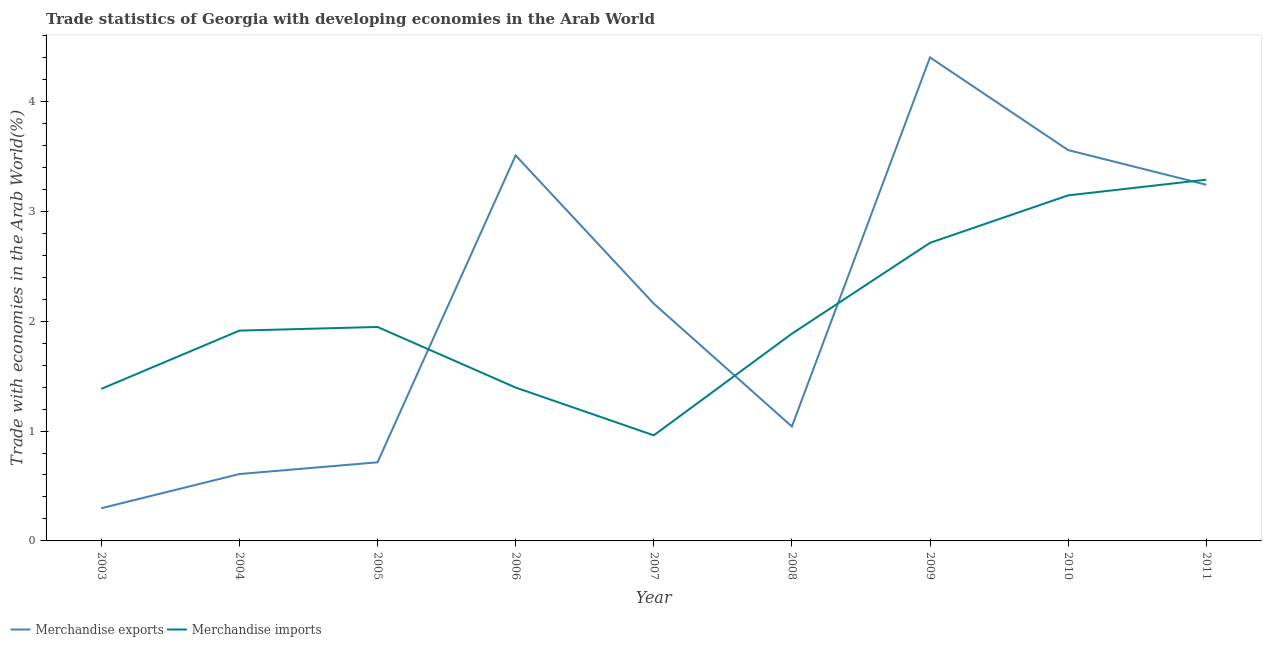Does the line corresponding to merchandise imports intersect with the line corresponding to merchandise exports?
Ensure brevity in your answer.  Yes. Is the number of lines equal to the number of legend labels?
Keep it short and to the point. Yes. What is the merchandise imports in 2004?
Make the answer very short. 1.91. Across all years, what is the maximum merchandise imports?
Your answer should be very brief. 3.29. Across all years, what is the minimum merchandise exports?
Your response must be concise. 0.3. In which year was the merchandise imports maximum?
Your answer should be compact. 2011. What is the total merchandise imports in the graph?
Your answer should be compact. 18.63. What is the difference between the merchandise imports in 2004 and that in 2008?
Provide a short and direct response. 0.03. What is the difference between the merchandise exports in 2003 and the merchandise imports in 2009?
Offer a terse response. -2.42. What is the average merchandise imports per year?
Keep it short and to the point. 2.07. In the year 2011, what is the difference between the merchandise exports and merchandise imports?
Offer a very short reply. -0.05. In how many years, is the merchandise exports greater than 4 %?
Your answer should be very brief. 1. What is the ratio of the merchandise imports in 2004 to that in 2009?
Ensure brevity in your answer.  0.71. Is the merchandise exports in 2007 less than that in 2008?
Ensure brevity in your answer.  No. Is the difference between the merchandise imports in 2003 and 2007 greater than the difference between the merchandise exports in 2003 and 2007?
Your answer should be compact. Yes. What is the difference between the highest and the second highest merchandise imports?
Your response must be concise. 0.14. What is the difference between the highest and the lowest merchandise exports?
Give a very brief answer. 4.1. In how many years, is the merchandise imports greater than the average merchandise imports taken over all years?
Keep it short and to the point. 3. How many lines are there?
Your answer should be very brief. 2. What is the difference between two consecutive major ticks on the Y-axis?
Your answer should be very brief. 1. Does the graph contain grids?
Give a very brief answer. No. How many legend labels are there?
Provide a short and direct response. 2. How are the legend labels stacked?
Provide a short and direct response. Horizontal. What is the title of the graph?
Keep it short and to the point. Trade statistics of Georgia with developing economies in the Arab World. What is the label or title of the X-axis?
Provide a short and direct response. Year. What is the label or title of the Y-axis?
Your answer should be compact. Trade with economies in the Arab World(%). What is the Trade with economies in the Arab World(%) of Merchandise exports in 2003?
Provide a short and direct response. 0.3. What is the Trade with economies in the Arab World(%) in Merchandise imports in 2003?
Provide a short and direct response. 1.38. What is the Trade with economies in the Arab World(%) in Merchandise exports in 2004?
Your answer should be compact. 0.61. What is the Trade with economies in the Arab World(%) of Merchandise imports in 2004?
Give a very brief answer. 1.91. What is the Trade with economies in the Arab World(%) of Merchandise exports in 2005?
Provide a short and direct response. 0.72. What is the Trade with economies in the Arab World(%) of Merchandise imports in 2005?
Your response must be concise. 1.95. What is the Trade with economies in the Arab World(%) in Merchandise exports in 2006?
Offer a very short reply. 3.51. What is the Trade with economies in the Arab World(%) of Merchandise imports in 2006?
Make the answer very short. 1.4. What is the Trade with economies in the Arab World(%) in Merchandise exports in 2007?
Your response must be concise. 2.16. What is the Trade with economies in the Arab World(%) in Merchandise imports in 2007?
Offer a very short reply. 0.96. What is the Trade with economies in the Arab World(%) in Merchandise exports in 2008?
Provide a succinct answer. 1.04. What is the Trade with economies in the Arab World(%) of Merchandise imports in 2008?
Your response must be concise. 1.89. What is the Trade with economies in the Arab World(%) of Merchandise exports in 2009?
Your answer should be very brief. 4.4. What is the Trade with economies in the Arab World(%) of Merchandise imports in 2009?
Make the answer very short. 2.71. What is the Trade with economies in the Arab World(%) of Merchandise exports in 2010?
Make the answer very short. 3.56. What is the Trade with economies in the Arab World(%) in Merchandise imports in 2010?
Your answer should be compact. 3.15. What is the Trade with economies in the Arab World(%) of Merchandise exports in 2011?
Provide a succinct answer. 3.24. What is the Trade with economies in the Arab World(%) in Merchandise imports in 2011?
Keep it short and to the point. 3.29. Across all years, what is the maximum Trade with economies in the Arab World(%) in Merchandise exports?
Your answer should be compact. 4.4. Across all years, what is the maximum Trade with economies in the Arab World(%) in Merchandise imports?
Offer a very short reply. 3.29. Across all years, what is the minimum Trade with economies in the Arab World(%) of Merchandise exports?
Your answer should be compact. 0.3. Across all years, what is the minimum Trade with economies in the Arab World(%) in Merchandise imports?
Ensure brevity in your answer.  0.96. What is the total Trade with economies in the Arab World(%) in Merchandise exports in the graph?
Provide a short and direct response. 19.53. What is the total Trade with economies in the Arab World(%) in Merchandise imports in the graph?
Provide a succinct answer. 18.63. What is the difference between the Trade with economies in the Arab World(%) in Merchandise exports in 2003 and that in 2004?
Keep it short and to the point. -0.31. What is the difference between the Trade with economies in the Arab World(%) in Merchandise imports in 2003 and that in 2004?
Provide a succinct answer. -0.53. What is the difference between the Trade with economies in the Arab World(%) in Merchandise exports in 2003 and that in 2005?
Give a very brief answer. -0.42. What is the difference between the Trade with economies in the Arab World(%) of Merchandise imports in 2003 and that in 2005?
Your answer should be very brief. -0.56. What is the difference between the Trade with economies in the Arab World(%) in Merchandise exports in 2003 and that in 2006?
Keep it short and to the point. -3.21. What is the difference between the Trade with economies in the Arab World(%) of Merchandise imports in 2003 and that in 2006?
Offer a terse response. -0.01. What is the difference between the Trade with economies in the Arab World(%) in Merchandise exports in 2003 and that in 2007?
Give a very brief answer. -1.86. What is the difference between the Trade with economies in the Arab World(%) in Merchandise imports in 2003 and that in 2007?
Your response must be concise. 0.42. What is the difference between the Trade with economies in the Arab World(%) of Merchandise exports in 2003 and that in 2008?
Offer a very short reply. -0.74. What is the difference between the Trade with economies in the Arab World(%) of Merchandise imports in 2003 and that in 2008?
Provide a succinct answer. -0.5. What is the difference between the Trade with economies in the Arab World(%) of Merchandise exports in 2003 and that in 2009?
Offer a very short reply. -4.1. What is the difference between the Trade with economies in the Arab World(%) of Merchandise imports in 2003 and that in 2009?
Offer a very short reply. -1.33. What is the difference between the Trade with economies in the Arab World(%) of Merchandise exports in 2003 and that in 2010?
Give a very brief answer. -3.26. What is the difference between the Trade with economies in the Arab World(%) of Merchandise imports in 2003 and that in 2010?
Offer a very short reply. -1.76. What is the difference between the Trade with economies in the Arab World(%) of Merchandise exports in 2003 and that in 2011?
Your answer should be compact. -2.94. What is the difference between the Trade with economies in the Arab World(%) in Merchandise imports in 2003 and that in 2011?
Make the answer very short. -1.9. What is the difference between the Trade with economies in the Arab World(%) of Merchandise exports in 2004 and that in 2005?
Offer a terse response. -0.11. What is the difference between the Trade with economies in the Arab World(%) of Merchandise imports in 2004 and that in 2005?
Provide a succinct answer. -0.03. What is the difference between the Trade with economies in the Arab World(%) in Merchandise exports in 2004 and that in 2006?
Keep it short and to the point. -2.9. What is the difference between the Trade with economies in the Arab World(%) of Merchandise imports in 2004 and that in 2006?
Give a very brief answer. 0.52. What is the difference between the Trade with economies in the Arab World(%) of Merchandise exports in 2004 and that in 2007?
Give a very brief answer. -1.55. What is the difference between the Trade with economies in the Arab World(%) in Merchandise imports in 2004 and that in 2007?
Give a very brief answer. 0.95. What is the difference between the Trade with economies in the Arab World(%) in Merchandise exports in 2004 and that in 2008?
Make the answer very short. -0.43. What is the difference between the Trade with economies in the Arab World(%) of Merchandise imports in 2004 and that in 2008?
Give a very brief answer. 0.03. What is the difference between the Trade with economies in the Arab World(%) in Merchandise exports in 2004 and that in 2009?
Provide a short and direct response. -3.79. What is the difference between the Trade with economies in the Arab World(%) in Merchandise imports in 2004 and that in 2009?
Your answer should be very brief. -0.8. What is the difference between the Trade with economies in the Arab World(%) in Merchandise exports in 2004 and that in 2010?
Your answer should be very brief. -2.95. What is the difference between the Trade with economies in the Arab World(%) in Merchandise imports in 2004 and that in 2010?
Provide a succinct answer. -1.23. What is the difference between the Trade with economies in the Arab World(%) in Merchandise exports in 2004 and that in 2011?
Give a very brief answer. -2.63. What is the difference between the Trade with economies in the Arab World(%) in Merchandise imports in 2004 and that in 2011?
Offer a very short reply. -1.37. What is the difference between the Trade with economies in the Arab World(%) of Merchandise exports in 2005 and that in 2006?
Your answer should be compact. -2.79. What is the difference between the Trade with economies in the Arab World(%) of Merchandise imports in 2005 and that in 2006?
Your answer should be compact. 0.55. What is the difference between the Trade with economies in the Arab World(%) of Merchandise exports in 2005 and that in 2007?
Your response must be concise. -1.44. What is the difference between the Trade with economies in the Arab World(%) of Merchandise imports in 2005 and that in 2007?
Your answer should be compact. 0.99. What is the difference between the Trade with economies in the Arab World(%) in Merchandise exports in 2005 and that in 2008?
Make the answer very short. -0.33. What is the difference between the Trade with economies in the Arab World(%) in Merchandise imports in 2005 and that in 2008?
Your answer should be compact. 0.06. What is the difference between the Trade with economies in the Arab World(%) in Merchandise exports in 2005 and that in 2009?
Offer a very short reply. -3.69. What is the difference between the Trade with economies in the Arab World(%) in Merchandise imports in 2005 and that in 2009?
Your response must be concise. -0.77. What is the difference between the Trade with economies in the Arab World(%) of Merchandise exports in 2005 and that in 2010?
Offer a very short reply. -2.84. What is the difference between the Trade with economies in the Arab World(%) in Merchandise imports in 2005 and that in 2010?
Provide a succinct answer. -1.2. What is the difference between the Trade with economies in the Arab World(%) in Merchandise exports in 2005 and that in 2011?
Offer a terse response. -2.53. What is the difference between the Trade with economies in the Arab World(%) of Merchandise imports in 2005 and that in 2011?
Your answer should be compact. -1.34. What is the difference between the Trade with economies in the Arab World(%) in Merchandise exports in 2006 and that in 2007?
Make the answer very short. 1.35. What is the difference between the Trade with economies in the Arab World(%) of Merchandise imports in 2006 and that in 2007?
Your response must be concise. 0.43. What is the difference between the Trade with economies in the Arab World(%) of Merchandise exports in 2006 and that in 2008?
Give a very brief answer. 2.47. What is the difference between the Trade with economies in the Arab World(%) in Merchandise imports in 2006 and that in 2008?
Make the answer very short. -0.49. What is the difference between the Trade with economies in the Arab World(%) of Merchandise exports in 2006 and that in 2009?
Offer a terse response. -0.89. What is the difference between the Trade with economies in the Arab World(%) in Merchandise imports in 2006 and that in 2009?
Offer a very short reply. -1.32. What is the difference between the Trade with economies in the Arab World(%) in Merchandise exports in 2006 and that in 2010?
Provide a succinct answer. -0.05. What is the difference between the Trade with economies in the Arab World(%) in Merchandise imports in 2006 and that in 2010?
Your answer should be compact. -1.75. What is the difference between the Trade with economies in the Arab World(%) in Merchandise exports in 2006 and that in 2011?
Provide a short and direct response. 0.27. What is the difference between the Trade with economies in the Arab World(%) in Merchandise imports in 2006 and that in 2011?
Offer a very short reply. -1.89. What is the difference between the Trade with economies in the Arab World(%) in Merchandise exports in 2007 and that in 2008?
Your response must be concise. 1.12. What is the difference between the Trade with economies in the Arab World(%) in Merchandise imports in 2007 and that in 2008?
Ensure brevity in your answer.  -0.93. What is the difference between the Trade with economies in the Arab World(%) of Merchandise exports in 2007 and that in 2009?
Provide a short and direct response. -2.24. What is the difference between the Trade with economies in the Arab World(%) in Merchandise imports in 2007 and that in 2009?
Keep it short and to the point. -1.75. What is the difference between the Trade with economies in the Arab World(%) in Merchandise exports in 2007 and that in 2010?
Offer a very short reply. -1.4. What is the difference between the Trade with economies in the Arab World(%) in Merchandise imports in 2007 and that in 2010?
Make the answer very short. -2.18. What is the difference between the Trade with economies in the Arab World(%) of Merchandise exports in 2007 and that in 2011?
Your answer should be compact. -1.08. What is the difference between the Trade with economies in the Arab World(%) of Merchandise imports in 2007 and that in 2011?
Offer a terse response. -2.33. What is the difference between the Trade with economies in the Arab World(%) of Merchandise exports in 2008 and that in 2009?
Offer a terse response. -3.36. What is the difference between the Trade with economies in the Arab World(%) of Merchandise imports in 2008 and that in 2009?
Offer a very short reply. -0.83. What is the difference between the Trade with economies in the Arab World(%) of Merchandise exports in 2008 and that in 2010?
Ensure brevity in your answer.  -2.52. What is the difference between the Trade with economies in the Arab World(%) in Merchandise imports in 2008 and that in 2010?
Provide a short and direct response. -1.26. What is the difference between the Trade with economies in the Arab World(%) in Merchandise exports in 2008 and that in 2011?
Give a very brief answer. -2.2. What is the difference between the Trade with economies in the Arab World(%) of Merchandise imports in 2008 and that in 2011?
Keep it short and to the point. -1.4. What is the difference between the Trade with economies in the Arab World(%) in Merchandise exports in 2009 and that in 2010?
Offer a very short reply. 0.84. What is the difference between the Trade with economies in the Arab World(%) in Merchandise imports in 2009 and that in 2010?
Your answer should be very brief. -0.43. What is the difference between the Trade with economies in the Arab World(%) in Merchandise exports in 2009 and that in 2011?
Your answer should be very brief. 1.16. What is the difference between the Trade with economies in the Arab World(%) of Merchandise imports in 2009 and that in 2011?
Provide a succinct answer. -0.57. What is the difference between the Trade with economies in the Arab World(%) in Merchandise exports in 2010 and that in 2011?
Offer a very short reply. 0.32. What is the difference between the Trade with economies in the Arab World(%) in Merchandise imports in 2010 and that in 2011?
Offer a terse response. -0.14. What is the difference between the Trade with economies in the Arab World(%) in Merchandise exports in 2003 and the Trade with economies in the Arab World(%) in Merchandise imports in 2004?
Provide a succinct answer. -1.62. What is the difference between the Trade with economies in the Arab World(%) in Merchandise exports in 2003 and the Trade with economies in the Arab World(%) in Merchandise imports in 2005?
Make the answer very short. -1.65. What is the difference between the Trade with economies in the Arab World(%) of Merchandise exports in 2003 and the Trade with economies in the Arab World(%) of Merchandise imports in 2006?
Provide a succinct answer. -1.1. What is the difference between the Trade with economies in the Arab World(%) in Merchandise exports in 2003 and the Trade with economies in the Arab World(%) in Merchandise imports in 2007?
Offer a terse response. -0.66. What is the difference between the Trade with economies in the Arab World(%) in Merchandise exports in 2003 and the Trade with economies in the Arab World(%) in Merchandise imports in 2008?
Your response must be concise. -1.59. What is the difference between the Trade with economies in the Arab World(%) of Merchandise exports in 2003 and the Trade with economies in the Arab World(%) of Merchandise imports in 2009?
Your answer should be compact. -2.42. What is the difference between the Trade with economies in the Arab World(%) of Merchandise exports in 2003 and the Trade with economies in the Arab World(%) of Merchandise imports in 2010?
Offer a terse response. -2.85. What is the difference between the Trade with economies in the Arab World(%) in Merchandise exports in 2003 and the Trade with economies in the Arab World(%) in Merchandise imports in 2011?
Your response must be concise. -2.99. What is the difference between the Trade with economies in the Arab World(%) of Merchandise exports in 2004 and the Trade with economies in the Arab World(%) of Merchandise imports in 2005?
Keep it short and to the point. -1.34. What is the difference between the Trade with economies in the Arab World(%) of Merchandise exports in 2004 and the Trade with economies in the Arab World(%) of Merchandise imports in 2006?
Give a very brief answer. -0.79. What is the difference between the Trade with economies in the Arab World(%) in Merchandise exports in 2004 and the Trade with economies in the Arab World(%) in Merchandise imports in 2007?
Your answer should be very brief. -0.35. What is the difference between the Trade with economies in the Arab World(%) of Merchandise exports in 2004 and the Trade with economies in the Arab World(%) of Merchandise imports in 2008?
Give a very brief answer. -1.28. What is the difference between the Trade with economies in the Arab World(%) in Merchandise exports in 2004 and the Trade with economies in the Arab World(%) in Merchandise imports in 2009?
Your answer should be very brief. -2.1. What is the difference between the Trade with economies in the Arab World(%) in Merchandise exports in 2004 and the Trade with economies in the Arab World(%) in Merchandise imports in 2010?
Give a very brief answer. -2.54. What is the difference between the Trade with economies in the Arab World(%) in Merchandise exports in 2004 and the Trade with economies in the Arab World(%) in Merchandise imports in 2011?
Ensure brevity in your answer.  -2.68. What is the difference between the Trade with economies in the Arab World(%) in Merchandise exports in 2005 and the Trade with economies in the Arab World(%) in Merchandise imports in 2006?
Keep it short and to the point. -0.68. What is the difference between the Trade with economies in the Arab World(%) of Merchandise exports in 2005 and the Trade with economies in the Arab World(%) of Merchandise imports in 2007?
Provide a short and direct response. -0.25. What is the difference between the Trade with economies in the Arab World(%) in Merchandise exports in 2005 and the Trade with economies in the Arab World(%) in Merchandise imports in 2008?
Ensure brevity in your answer.  -1.17. What is the difference between the Trade with economies in the Arab World(%) of Merchandise exports in 2005 and the Trade with economies in the Arab World(%) of Merchandise imports in 2009?
Make the answer very short. -2. What is the difference between the Trade with economies in the Arab World(%) of Merchandise exports in 2005 and the Trade with economies in the Arab World(%) of Merchandise imports in 2010?
Your answer should be compact. -2.43. What is the difference between the Trade with economies in the Arab World(%) of Merchandise exports in 2005 and the Trade with economies in the Arab World(%) of Merchandise imports in 2011?
Offer a very short reply. -2.57. What is the difference between the Trade with economies in the Arab World(%) in Merchandise exports in 2006 and the Trade with economies in the Arab World(%) in Merchandise imports in 2007?
Your answer should be very brief. 2.55. What is the difference between the Trade with economies in the Arab World(%) of Merchandise exports in 2006 and the Trade with economies in the Arab World(%) of Merchandise imports in 2008?
Make the answer very short. 1.62. What is the difference between the Trade with economies in the Arab World(%) in Merchandise exports in 2006 and the Trade with economies in the Arab World(%) in Merchandise imports in 2009?
Give a very brief answer. 0.8. What is the difference between the Trade with economies in the Arab World(%) in Merchandise exports in 2006 and the Trade with economies in the Arab World(%) in Merchandise imports in 2010?
Keep it short and to the point. 0.36. What is the difference between the Trade with economies in the Arab World(%) in Merchandise exports in 2006 and the Trade with economies in the Arab World(%) in Merchandise imports in 2011?
Offer a very short reply. 0.22. What is the difference between the Trade with economies in the Arab World(%) in Merchandise exports in 2007 and the Trade with economies in the Arab World(%) in Merchandise imports in 2008?
Provide a short and direct response. 0.27. What is the difference between the Trade with economies in the Arab World(%) in Merchandise exports in 2007 and the Trade with economies in the Arab World(%) in Merchandise imports in 2009?
Make the answer very short. -0.55. What is the difference between the Trade with economies in the Arab World(%) in Merchandise exports in 2007 and the Trade with economies in the Arab World(%) in Merchandise imports in 2010?
Your answer should be very brief. -0.99. What is the difference between the Trade with economies in the Arab World(%) of Merchandise exports in 2007 and the Trade with economies in the Arab World(%) of Merchandise imports in 2011?
Your answer should be compact. -1.13. What is the difference between the Trade with economies in the Arab World(%) in Merchandise exports in 2008 and the Trade with economies in the Arab World(%) in Merchandise imports in 2009?
Provide a succinct answer. -1.67. What is the difference between the Trade with economies in the Arab World(%) in Merchandise exports in 2008 and the Trade with economies in the Arab World(%) in Merchandise imports in 2010?
Your response must be concise. -2.1. What is the difference between the Trade with economies in the Arab World(%) of Merchandise exports in 2008 and the Trade with economies in the Arab World(%) of Merchandise imports in 2011?
Ensure brevity in your answer.  -2.25. What is the difference between the Trade with economies in the Arab World(%) of Merchandise exports in 2009 and the Trade with economies in the Arab World(%) of Merchandise imports in 2010?
Your answer should be compact. 1.26. What is the difference between the Trade with economies in the Arab World(%) in Merchandise exports in 2009 and the Trade with economies in the Arab World(%) in Merchandise imports in 2011?
Provide a short and direct response. 1.11. What is the difference between the Trade with economies in the Arab World(%) of Merchandise exports in 2010 and the Trade with economies in the Arab World(%) of Merchandise imports in 2011?
Offer a very short reply. 0.27. What is the average Trade with economies in the Arab World(%) of Merchandise exports per year?
Ensure brevity in your answer.  2.17. What is the average Trade with economies in the Arab World(%) in Merchandise imports per year?
Give a very brief answer. 2.07. In the year 2003, what is the difference between the Trade with economies in the Arab World(%) in Merchandise exports and Trade with economies in the Arab World(%) in Merchandise imports?
Provide a short and direct response. -1.09. In the year 2004, what is the difference between the Trade with economies in the Arab World(%) of Merchandise exports and Trade with economies in the Arab World(%) of Merchandise imports?
Provide a short and direct response. -1.31. In the year 2005, what is the difference between the Trade with economies in the Arab World(%) of Merchandise exports and Trade with economies in the Arab World(%) of Merchandise imports?
Provide a succinct answer. -1.23. In the year 2006, what is the difference between the Trade with economies in the Arab World(%) of Merchandise exports and Trade with economies in the Arab World(%) of Merchandise imports?
Provide a succinct answer. 2.11. In the year 2007, what is the difference between the Trade with economies in the Arab World(%) in Merchandise exports and Trade with economies in the Arab World(%) in Merchandise imports?
Your response must be concise. 1.2. In the year 2008, what is the difference between the Trade with economies in the Arab World(%) in Merchandise exports and Trade with economies in the Arab World(%) in Merchandise imports?
Provide a succinct answer. -0.84. In the year 2009, what is the difference between the Trade with economies in the Arab World(%) in Merchandise exports and Trade with economies in the Arab World(%) in Merchandise imports?
Provide a succinct answer. 1.69. In the year 2010, what is the difference between the Trade with economies in the Arab World(%) in Merchandise exports and Trade with economies in the Arab World(%) in Merchandise imports?
Keep it short and to the point. 0.41. In the year 2011, what is the difference between the Trade with economies in the Arab World(%) of Merchandise exports and Trade with economies in the Arab World(%) of Merchandise imports?
Ensure brevity in your answer.  -0.05. What is the ratio of the Trade with economies in the Arab World(%) of Merchandise exports in 2003 to that in 2004?
Your answer should be very brief. 0.49. What is the ratio of the Trade with economies in the Arab World(%) in Merchandise imports in 2003 to that in 2004?
Offer a very short reply. 0.72. What is the ratio of the Trade with economies in the Arab World(%) of Merchandise exports in 2003 to that in 2005?
Your answer should be very brief. 0.42. What is the ratio of the Trade with economies in the Arab World(%) in Merchandise imports in 2003 to that in 2005?
Make the answer very short. 0.71. What is the ratio of the Trade with economies in the Arab World(%) of Merchandise exports in 2003 to that in 2006?
Provide a short and direct response. 0.08. What is the ratio of the Trade with economies in the Arab World(%) in Merchandise exports in 2003 to that in 2007?
Give a very brief answer. 0.14. What is the ratio of the Trade with economies in the Arab World(%) of Merchandise imports in 2003 to that in 2007?
Your response must be concise. 1.44. What is the ratio of the Trade with economies in the Arab World(%) in Merchandise exports in 2003 to that in 2008?
Ensure brevity in your answer.  0.29. What is the ratio of the Trade with economies in the Arab World(%) in Merchandise imports in 2003 to that in 2008?
Provide a short and direct response. 0.73. What is the ratio of the Trade with economies in the Arab World(%) of Merchandise exports in 2003 to that in 2009?
Make the answer very short. 0.07. What is the ratio of the Trade with economies in the Arab World(%) of Merchandise imports in 2003 to that in 2009?
Provide a short and direct response. 0.51. What is the ratio of the Trade with economies in the Arab World(%) in Merchandise exports in 2003 to that in 2010?
Make the answer very short. 0.08. What is the ratio of the Trade with economies in the Arab World(%) in Merchandise imports in 2003 to that in 2010?
Your response must be concise. 0.44. What is the ratio of the Trade with economies in the Arab World(%) in Merchandise exports in 2003 to that in 2011?
Your response must be concise. 0.09. What is the ratio of the Trade with economies in the Arab World(%) of Merchandise imports in 2003 to that in 2011?
Ensure brevity in your answer.  0.42. What is the ratio of the Trade with economies in the Arab World(%) in Merchandise exports in 2004 to that in 2005?
Offer a very short reply. 0.85. What is the ratio of the Trade with economies in the Arab World(%) of Merchandise imports in 2004 to that in 2005?
Your answer should be compact. 0.98. What is the ratio of the Trade with economies in the Arab World(%) of Merchandise exports in 2004 to that in 2006?
Keep it short and to the point. 0.17. What is the ratio of the Trade with economies in the Arab World(%) in Merchandise imports in 2004 to that in 2006?
Give a very brief answer. 1.37. What is the ratio of the Trade with economies in the Arab World(%) of Merchandise exports in 2004 to that in 2007?
Keep it short and to the point. 0.28. What is the ratio of the Trade with economies in the Arab World(%) in Merchandise imports in 2004 to that in 2007?
Your answer should be very brief. 1.99. What is the ratio of the Trade with economies in the Arab World(%) in Merchandise exports in 2004 to that in 2008?
Keep it short and to the point. 0.58. What is the ratio of the Trade with economies in the Arab World(%) in Merchandise imports in 2004 to that in 2008?
Your answer should be compact. 1.01. What is the ratio of the Trade with economies in the Arab World(%) in Merchandise exports in 2004 to that in 2009?
Provide a succinct answer. 0.14. What is the ratio of the Trade with economies in the Arab World(%) of Merchandise imports in 2004 to that in 2009?
Offer a terse response. 0.71. What is the ratio of the Trade with economies in the Arab World(%) in Merchandise exports in 2004 to that in 2010?
Keep it short and to the point. 0.17. What is the ratio of the Trade with economies in the Arab World(%) of Merchandise imports in 2004 to that in 2010?
Your answer should be very brief. 0.61. What is the ratio of the Trade with economies in the Arab World(%) in Merchandise exports in 2004 to that in 2011?
Your answer should be very brief. 0.19. What is the ratio of the Trade with economies in the Arab World(%) in Merchandise imports in 2004 to that in 2011?
Offer a very short reply. 0.58. What is the ratio of the Trade with economies in the Arab World(%) in Merchandise exports in 2005 to that in 2006?
Ensure brevity in your answer.  0.2. What is the ratio of the Trade with economies in the Arab World(%) of Merchandise imports in 2005 to that in 2006?
Ensure brevity in your answer.  1.39. What is the ratio of the Trade with economies in the Arab World(%) of Merchandise exports in 2005 to that in 2007?
Provide a succinct answer. 0.33. What is the ratio of the Trade with economies in the Arab World(%) in Merchandise imports in 2005 to that in 2007?
Keep it short and to the point. 2.03. What is the ratio of the Trade with economies in the Arab World(%) in Merchandise exports in 2005 to that in 2008?
Keep it short and to the point. 0.69. What is the ratio of the Trade with economies in the Arab World(%) of Merchandise imports in 2005 to that in 2008?
Provide a short and direct response. 1.03. What is the ratio of the Trade with economies in the Arab World(%) in Merchandise exports in 2005 to that in 2009?
Make the answer very short. 0.16. What is the ratio of the Trade with economies in the Arab World(%) in Merchandise imports in 2005 to that in 2009?
Your answer should be very brief. 0.72. What is the ratio of the Trade with economies in the Arab World(%) in Merchandise exports in 2005 to that in 2010?
Offer a very short reply. 0.2. What is the ratio of the Trade with economies in the Arab World(%) in Merchandise imports in 2005 to that in 2010?
Provide a succinct answer. 0.62. What is the ratio of the Trade with economies in the Arab World(%) of Merchandise exports in 2005 to that in 2011?
Your answer should be very brief. 0.22. What is the ratio of the Trade with economies in the Arab World(%) in Merchandise imports in 2005 to that in 2011?
Give a very brief answer. 0.59. What is the ratio of the Trade with economies in the Arab World(%) in Merchandise exports in 2006 to that in 2007?
Your answer should be compact. 1.62. What is the ratio of the Trade with economies in the Arab World(%) of Merchandise imports in 2006 to that in 2007?
Give a very brief answer. 1.45. What is the ratio of the Trade with economies in the Arab World(%) in Merchandise exports in 2006 to that in 2008?
Give a very brief answer. 3.37. What is the ratio of the Trade with economies in the Arab World(%) of Merchandise imports in 2006 to that in 2008?
Make the answer very short. 0.74. What is the ratio of the Trade with economies in the Arab World(%) of Merchandise exports in 2006 to that in 2009?
Give a very brief answer. 0.8. What is the ratio of the Trade with economies in the Arab World(%) of Merchandise imports in 2006 to that in 2009?
Provide a short and direct response. 0.51. What is the ratio of the Trade with economies in the Arab World(%) in Merchandise exports in 2006 to that in 2010?
Your answer should be very brief. 0.99. What is the ratio of the Trade with economies in the Arab World(%) in Merchandise imports in 2006 to that in 2010?
Provide a short and direct response. 0.44. What is the ratio of the Trade with economies in the Arab World(%) of Merchandise exports in 2006 to that in 2011?
Your answer should be compact. 1.08. What is the ratio of the Trade with economies in the Arab World(%) of Merchandise imports in 2006 to that in 2011?
Your answer should be compact. 0.42. What is the ratio of the Trade with economies in the Arab World(%) of Merchandise exports in 2007 to that in 2008?
Offer a terse response. 2.07. What is the ratio of the Trade with economies in the Arab World(%) of Merchandise imports in 2007 to that in 2008?
Your answer should be very brief. 0.51. What is the ratio of the Trade with economies in the Arab World(%) in Merchandise exports in 2007 to that in 2009?
Offer a very short reply. 0.49. What is the ratio of the Trade with economies in the Arab World(%) of Merchandise imports in 2007 to that in 2009?
Your response must be concise. 0.35. What is the ratio of the Trade with economies in the Arab World(%) of Merchandise exports in 2007 to that in 2010?
Give a very brief answer. 0.61. What is the ratio of the Trade with economies in the Arab World(%) of Merchandise imports in 2007 to that in 2010?
Provide a succinct answer. 0.31. What is the ratio of the Trade with economies in the Arab World(%) in Merchandise exports in 2007 to that in 2011?
Provide a succinct answer. 0.67. What is the ratio of the Trade with economies in the Arab World(%) in Merchandise imports in 2007 to that in 2011?
Offer a very short reply. 0.29. What is the ratio of the Trade with economies in the Arab World(%) of Merchandise exports in 2008 to that in 2009?
Give a very brief answer. 0.24. What is the ratio of the Trade with economies in the Arab World(%) in Merchandise imports in 2008 to that in 2009?
Your response must be concise. 0.7. What is the ratio of the Trade with economies in the Arab World(%) in Merchandise exports in 2008 to that in 2010?
Your answer should be compact. 0.29. What is the ratio of the Trade with economies in the Arab World(%) of Merchandise imports in 2008 to that in 2010?
Provide a short and direct response. 0.6. What is the ratio of the Trade with economies in the Arab World(%) in Merchandise exports in 2008 to that in 2011?
Your answer should be compact. 0.32. What is the ratio of the Trade with economies in the Arab World(%) in Merchandise imports in 2008 to that in 2011?
Keep it short and to the point. 0.57. What is the ratio of the Trade with economies in the Arab World(%) of Merchandise exports in 2009 to that in 2010?
Provide a short and direct response. 1.24. What is the ratio of the Trade with economies in the Arab World(%) of Merchandise imports in 2009 to that in 2010?
Offer a very short reply. 0.86. What is the ratio of the Trade with economies in the Arab World(%) in Merchandise exports in 2009 to that in 2011?
Make the answer very short. 1.36. What is the ratio of the Trade with economies in the Arab World(%) in Merchandise imports in 2009 to that in 2011?
Your response must be concise. 0.83. What is the ratio of the Trade with economies in the Arab World(%) in Merchandise exports in 2010 to that in 2011?
Your answer should be very brief. 1.1. What is the ratio of the Trade with economies in the Arab World(%) of Merchandise imports in 2010 to that in 2011?
Keep it short and to the point. 0.96. What is the difference between the highest and the second highest Trade with economies in the Arab World(%) in Merchandise exports?
Your answer should be very brief. 0.84. What is the difference between the highest and the second highest Trade with economies in the Arab World(%) in Merchandise imports?
Your answer should be very brief. 0.14. What is the difference between the highest and the lowest Trade with economies in the Arab World(%) of Merchandise exports?
Provide a succinct answer. 4.1. What is the difference between the highest and the lowest Trade with economies in the Arab World(%) in Merchandise imports?
Make the answer very short. 2.33. 